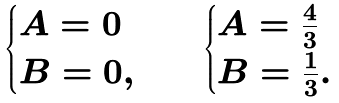Convert formula to latex. <formula><loc_0><loc_0><loc_500><loc_500>\begin{cases} A = 0 \\ B = 0 , \end{cases} \quad \begin{cases} A = \frac { 4 } { 3 } \\ B = \frac { 1 } { 3 } . \end{cases}</formula> 